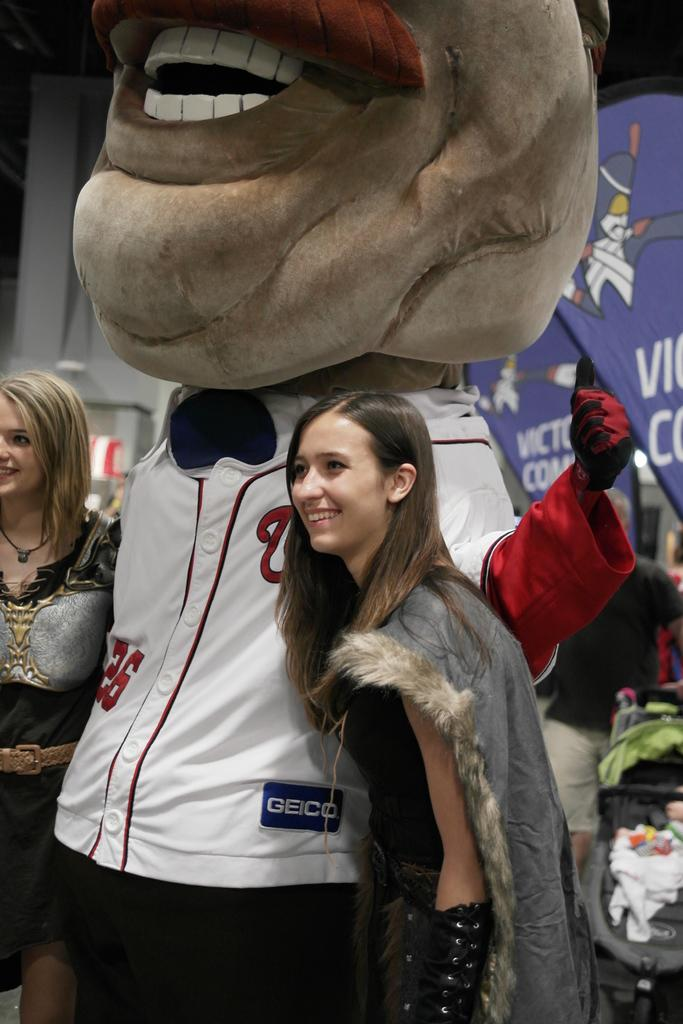<image>
Provide a brief description of the given image. a girl standing next to a character with a W on their shirt 